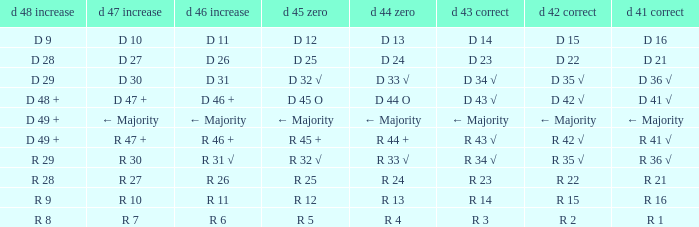What is the value of D 45 O, when the value of D 41 √ is r 41 √? R 45 +. 